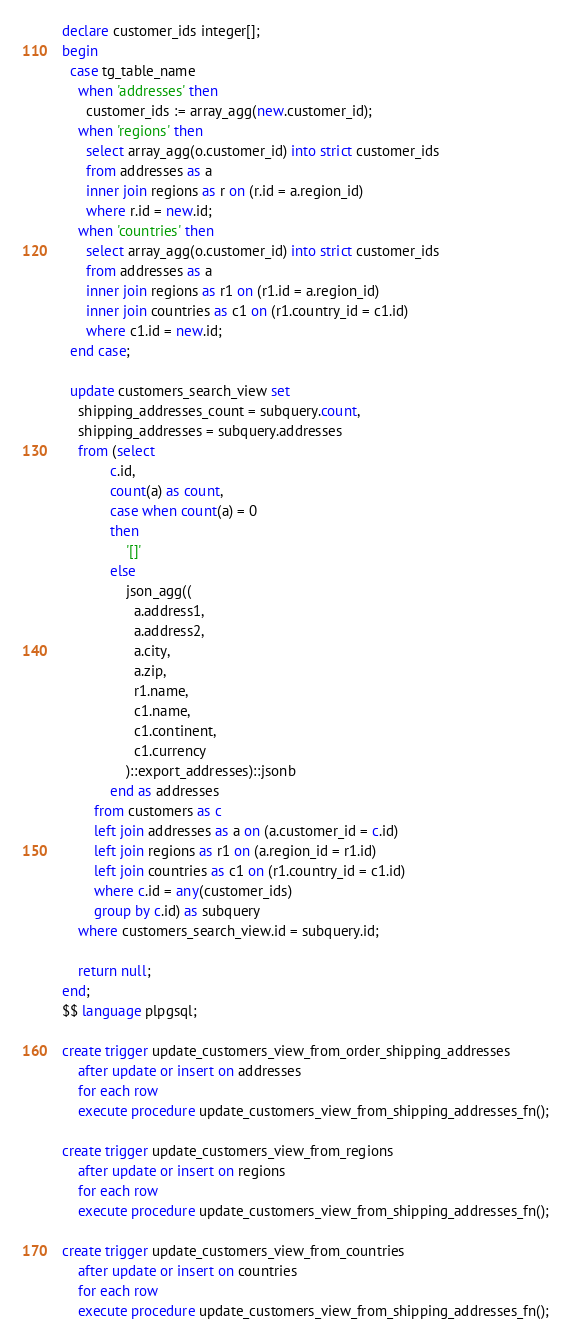<code> <loc_0><loc_0><loc_500><loc_500><_SQL_>declare customer_ids integer[];
begin
  case tg_table_name
    when 'addresses' then
      customer_ids := array_agg(new.customer_id);
    when 'regions' then
      select array_agg(o.customer_id) into strict customer_ids
      from addresses as a
      inner join regions as r on (r.id = a.region_id)
      where r.id = new.id;
    when 'countries' then
      select array_agg(o.customer_id) into strict customer_ids
      from addresses as a
      inner join regions as r1 on (r1.id = a.region_id)
      inner join countries as c1 on (r1.country_id = c1.id)
      where c1.id = new.id;
  end case;

  update customers_search_view set
    shipping_addresses_count = subquery.count,
    shipping_addresses = subquery.addresses
    from (select
            c.id,
            count(a) as count,
            case when count(a) = 0
            then
                '[]'
            else
                json_agg((
                  a.address1, 
                  a.address2, 
                  a.city, 
                  a.zip, 
                  r1.name, 
                  c1.name, 
                  c1.continent, 
                  c1.currency
                )::export_addresses)::jsonb
            end as addresses
        from customers as c
        left join addresses as a on (a.customer_id = c.id)
        left join regions as r1 on (a.region_id = r1.id)
        left join countries as c1 on (r1.country_id = c1.id)
        where c.id = any(customer_ids)
        group by c.id) as subquery
    where customers_search_view.id = subquery.id;

    return null;
end;
$$ language plpgsql;

create trigger update_customers_view_from_order_shipping_addresses
    after update or insert on addresses
    for each row
    execute procedure update_customers_view_from_shipping_addresses_fn();

create trigger update_customers_view_from_regions
    after update or insert on regions
    for each row
    execute procedure update_customers_view_from_shipping_addresses_fn();

create trigger update_customers_view_from_countries
    after update or insert on countries
    for each row
    execute procedure update_customers_view_from_shipping_addresses_fn();
</code> 